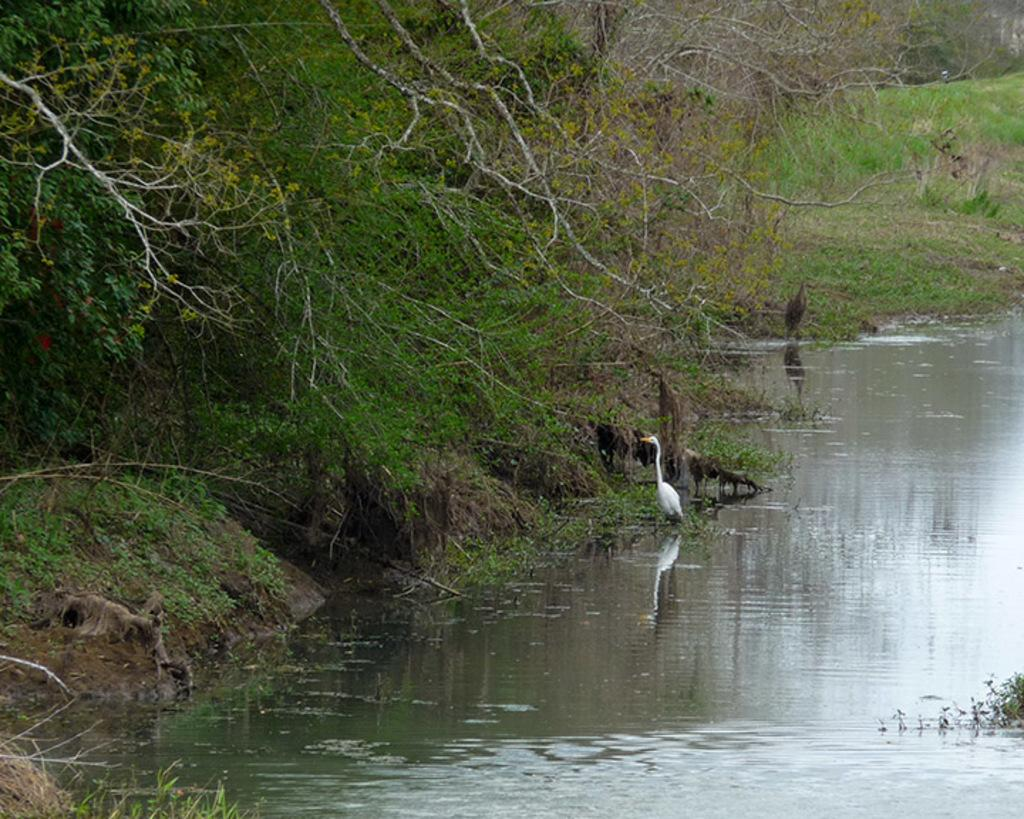What is visible in the image? Water is visible in the image. What is on the water in the image? There are birds on the water. What type of vegetation is present in the image? There are trees in the image. What color is the war in the image? There is no war present in the image, and therefore no color can be attributed to it. What form does the war take in the image? There is no war present in the image, and therefore no form can be attributed to it. 